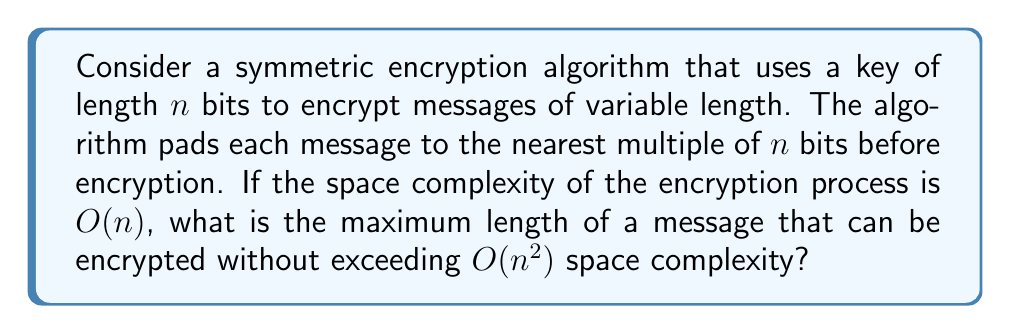Help me with this question. To solve this problem, let's approach it step-by-step:

1) Let $m$ be the length of the message in bits.

2) The encryption algorithm pads the message to the nearest multiple of $n$. So, the padded message length is at most $m + n - 1$ bits.

3) Given that the space complexity of the encryption process is $O(n)$, this means that the working space used by the algorithm (excluding input and output) is proportional to $n$.

4) The total space complexity would include:
   - Space for the key: $O(n)$
   - Space for the padded message: $O(m + n)$
   - Working space for encryption: $O(n)$

5) The total space complexity is thus $O(m + n)$.

6) We want this to not exceed $O(n^2)$, so:

   $O(m + n) \leq O(n^2)$

7) This inequality holds when $m \leq cn^2$ for some constant $c$.

8) Therefore, the maximum length of the message that can be encrypted without exceeding $O(n^2)$ space complexity is $O(n^2)$.
Answer: The maximum length of a message that can be encrypted without exceeding $O(n^2)$ space complexity is $O(n^2)$ bits, where $n$ is the key length in bits. 